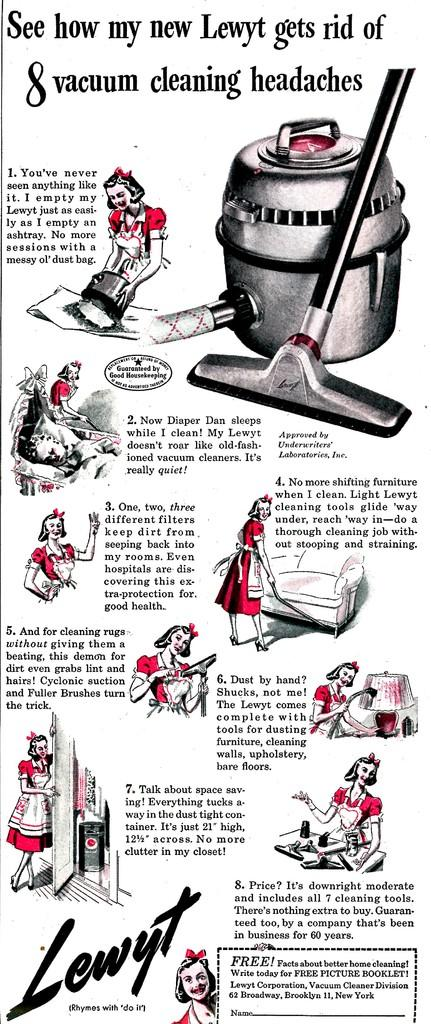<image>
Describe the image concisely. An advertisement for Lewyt vacuums shows how it gets rid of 8 vacuum cleaning headaches. 